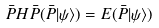<formula> <loc_0><loc_0><loc_500><loc_500>\bar { P } H \bar { P } ( \bar { P } | \psi \rangle ) = E ( \bar { P } | \psi \rangle )</formula> 